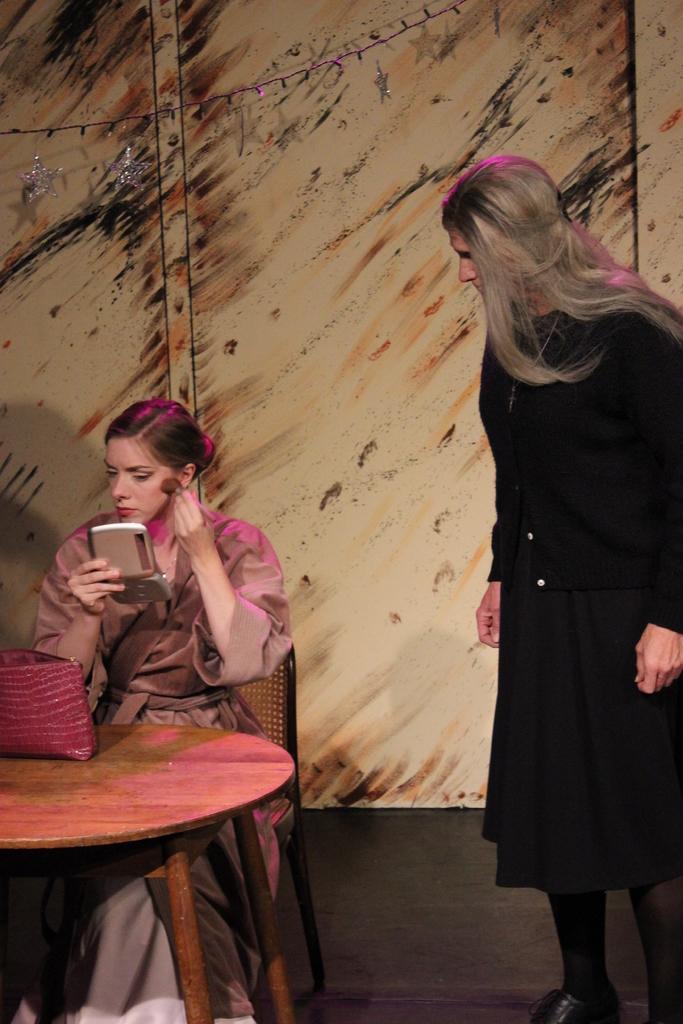Could you give a brief overview of what you see in this image? In this picture this person sitting on the chair and holding a thing and holding a brush. This person standing. There is a table. On the table we can see a bag. On the background we can see a wall and lights. 